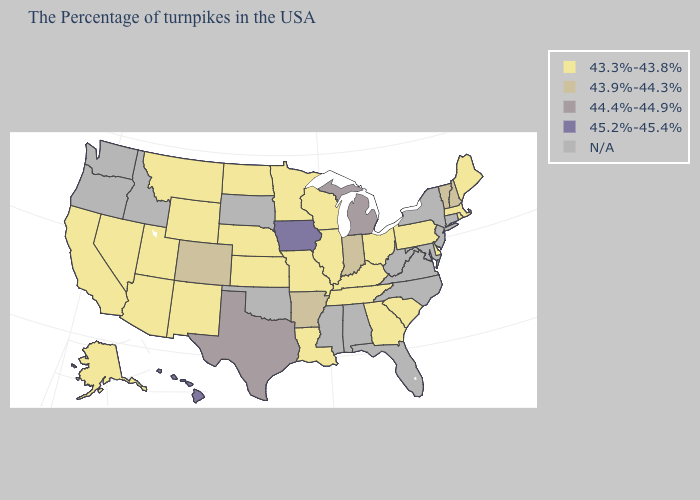Name the states that have a value in the range 43.9%-44.3%?
Give a very brief answer. New Hampshire, Vermont, Indiana, Arkansas, Colorado. Name the states that have a value in the range N/A?
Keep it brief. Connecticut, New York, New Jersey, Maryland, Virginia, North Carolina, West Virginia, Florida, Alabama, Mississippi, Oklahoma, South Dakota, Idaho, Washington, Oregon. What is the value of Idaho?
Keep it brief. N/A. Does the map have missing data?
Answer briefly. Yes. What is the value of Montana?
Give a very brief answer. 43.3%-43.8%. Which states have the highest value in the USA?
Quick response, please. Iowa, Hawaii. Name the states that have a value in the range 43.3%-43.8%?
Answer briefly. Maine, Massachusetts, Rhode Island, Delaware, Pennsylvania, South Carolina, Ohio, Georgia, Kentucky, Tennessee, Wisconsin, Illinois, Louisiana, Missouri, Minnesota, Kansas, Nebraska, North Dakota, Wyoming, New Mexico, Utah, Montana, Arizona, Nevada, California, Alaska. What is the value of Nebraska?
Give a very brief answer. 43.3%-43.8%. Name the states that have a value in the range N/A?
Short answer required. Connecticut, New York, New Jersey, Maryland, Virginia, North Carolina, West Virginia, Florida, Alabama, Mississippi, Oklahoma, South Dakota, Idaho, Washington, Oregon. Does the first symbol in the legend represent the smallest category?
Keep it brief. Yes. What is the value of Georgia?
Write a very short answer. 43.3%-43.8%. Name the states that have a value in the range 43.9%-44.3%?
Be succinct. New Hampshire, Vermont, Indiana, Arkansas, Colorado. What is the value of Arkansas?
Give a very brief answer. 43.9%-44.3%. Among the states that border New Jersey , which have the lowest value?
Short answer required. Delaware, Pennsylvania. What is the lowest value in states that border Rhode Island?
Keep it brief. 43.3%-43.8%. 